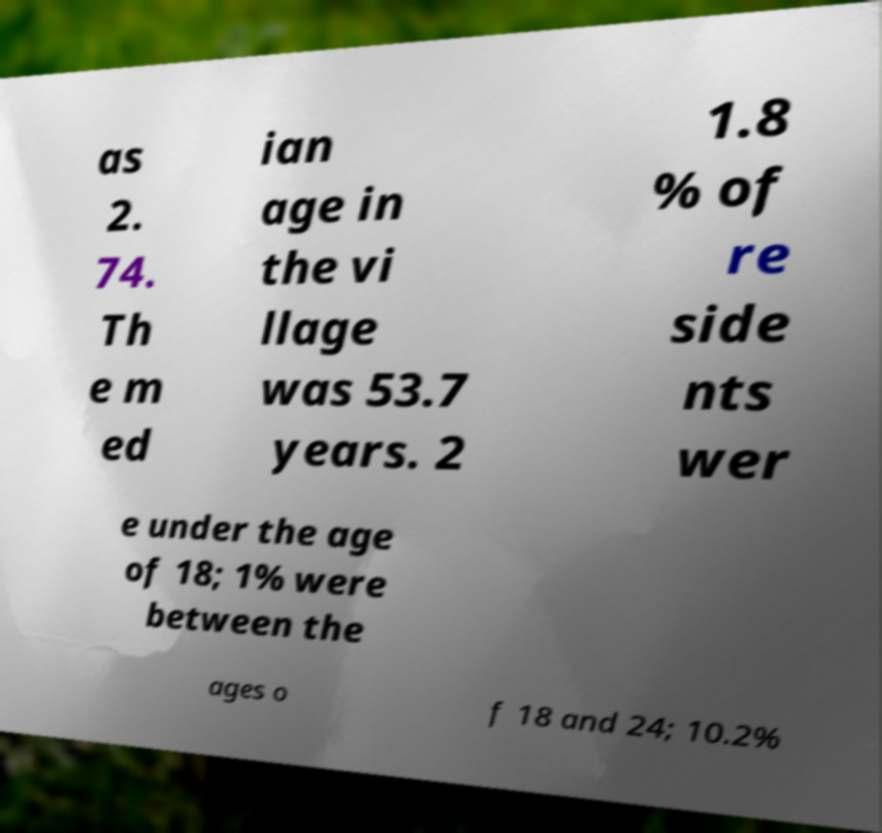Please identify and transcribe the text found in this image. as 2. 74. Th e m ed ian age in the vi llage was 53.7 years. 2 1.8 % of re side nts wer e under the age of 18; 1% were between the ages o f 18 and 24; 10.2% 